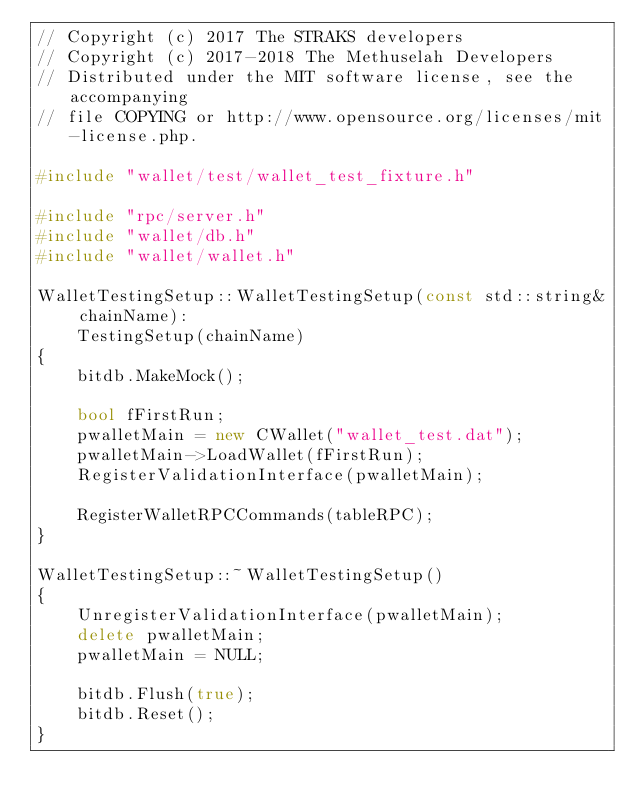<code> <loc_0><loc_0><loc_500><loc_500><_C++_>// Copyright (c) 2017 The STRAKS developers
// Copyright (c) 2017-2018 The Methuselah Developers
// Distributed under the MIT software license, see the accompanying
// file COPYING or http://www.opensource.org/licenses/mit-license.php.

#include "wallet/test/wallet_test_fixture.h"

#include "rpc/server.h"
#include "wallet/db.h"
#include "wallet/wallet.h"

WalletTestingSetup::WalletTestingSetup(const std::string& chainName):
    TestingSetup(chainName)
{
    bitdb.MakeMock();

    bool fFirstRun;
    pwalletMain = new CWallet("wallet_test.dat");
    pwalletMain->LoadWallet(fFirstRun);
    RegisterValidationInterface(pwalletMain);

    RegisterWalletRPCCommands(tableRPC);
}

WalletTestingSetup::~WalletTestingSetup()
{
    UnregisterValidationInterface(pwalletMain);
    delete pwalletMain;
    pwalletMain = NULL;

    bitdb.Flush(true);
    bitdb.Reset();
}
</code> 